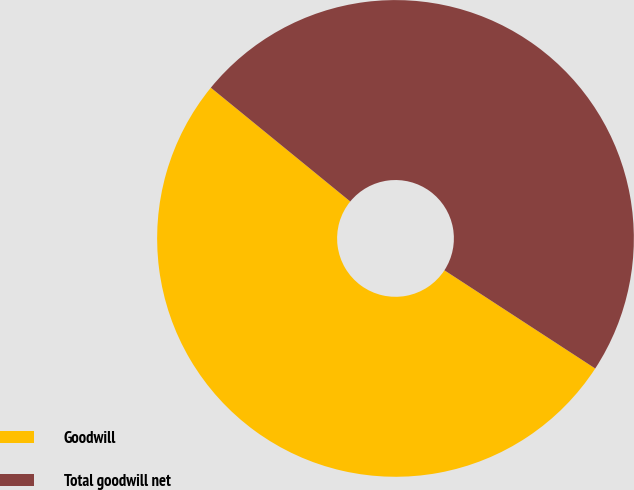<chart> <loc_0><loc_0><loc_500><loc_500><pie_chart><fcel>Goodwill<fcel>Total goodwill net<nl><fcel>51.71%<fcel>48.29%<nl></chart> 